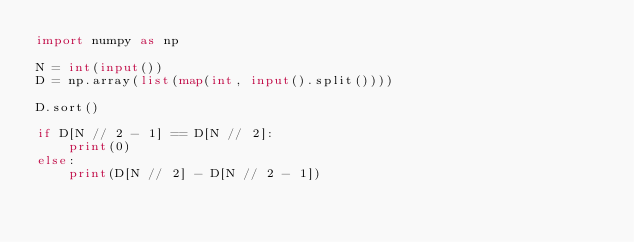<code> <loc_0><loc_0><loc_500><loc_500><_Python_>import numpy as np

N = int(input())
D = np.array(list(map(int, input().split())))

D.sort()

if D[N // 2 - 1] == D[N // 2]:
    print(0)
else:
    print(D[N // 2] - D[N // 2 - 1])
</code> 